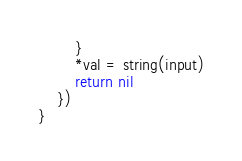<code> <loc_0><loc_0><loc_500><loc_500><_Go_>		}
		*val = string(input)
		return nil
	})
}
</code> 